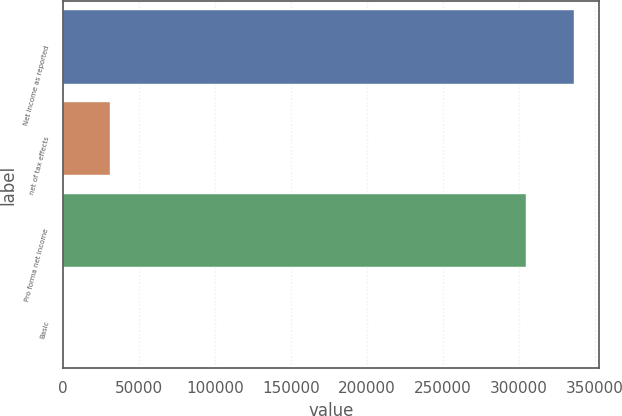Convert chart to OTSL. <chart><loc_0><loc_0><loc_500><loc_500><bar_chart><fcel>Net income as reported<fcel>net of tax effects<fcel>Pro forma net income<fcel>Basic<nl><fcel>336027<fcel>31123.2<fcel>304905<fcel>1.44<nl></chart> 